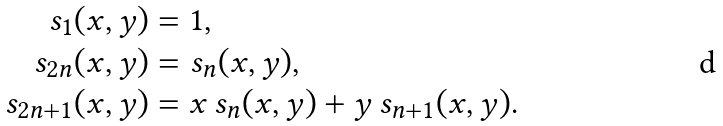<formula> <loc_0><loc_0><loc_500><loc_500>s _ { 1 } ( x , y ) & = 1 , \\ s _ { 2 n } ( x , y ) & = s _ { n } ( x , y ) , \\ s _ { 2 n + 1 } ( x , y ) & = x \, s _ { n } ( x , y ) + y \, s _ { n + 1 } ( x , y ) .</formula> 